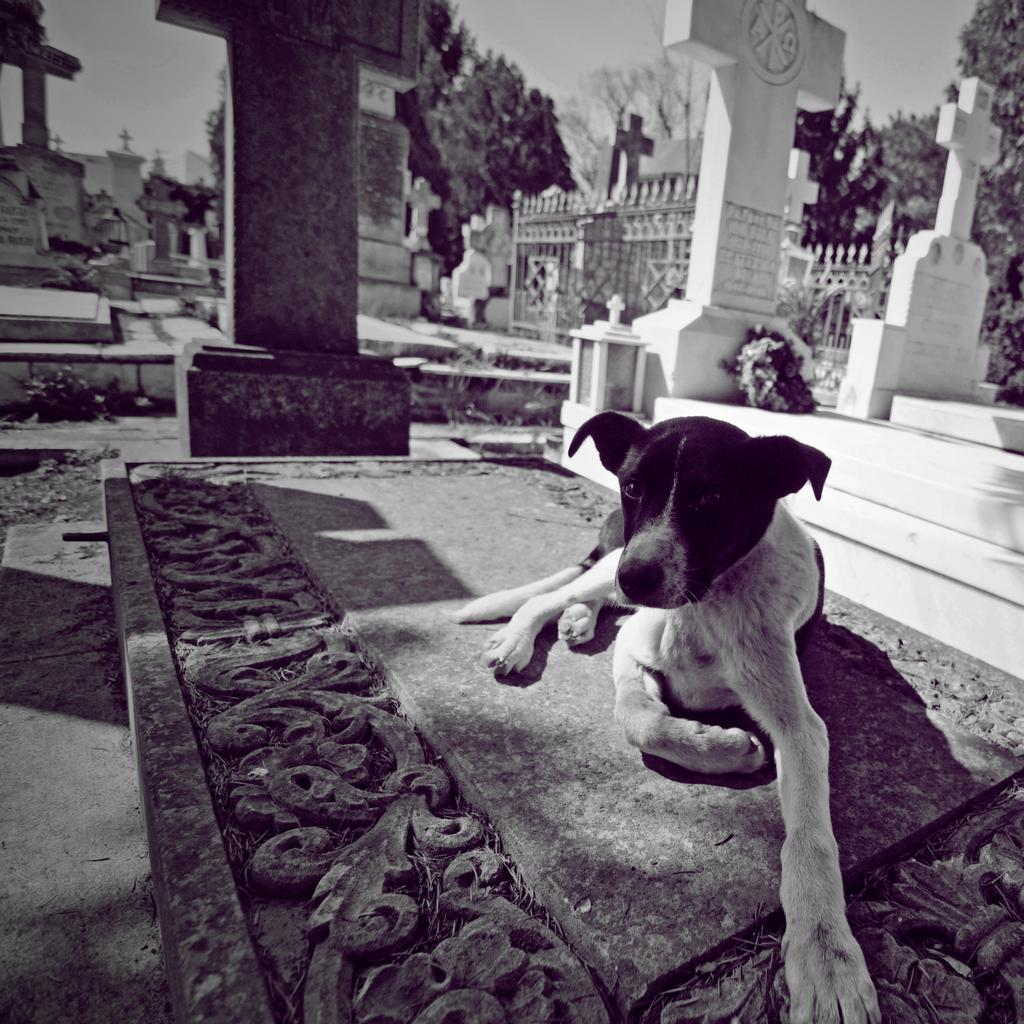What type of animal can be seen in the image? There is a dog in the image. What can be seen in the distance behind the dog? There are cemeteries and trees in the background of the image. What is the color scheme of the image? The image is in black and white. Where is the volcano located in the image? There is no volcano present in the image. How many ants can be seen crawling on the dog in the image? There are no ants visible in the image; it features a dog with no insects present. 